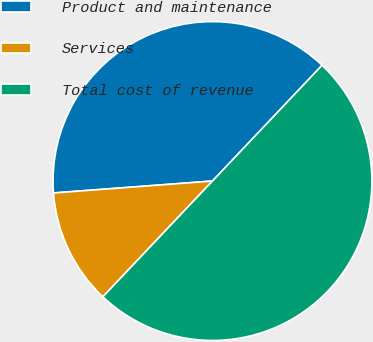Convert chart. <chart><loc_0><loc_0><loc_500><loc_500><pie_chart><fcel>Product and maintenance<fcel>Services<fcel>Total cost of revenue<nl><fcel>38.26%<fcel>11.74%<fcel>50.0%<nl></chart> 